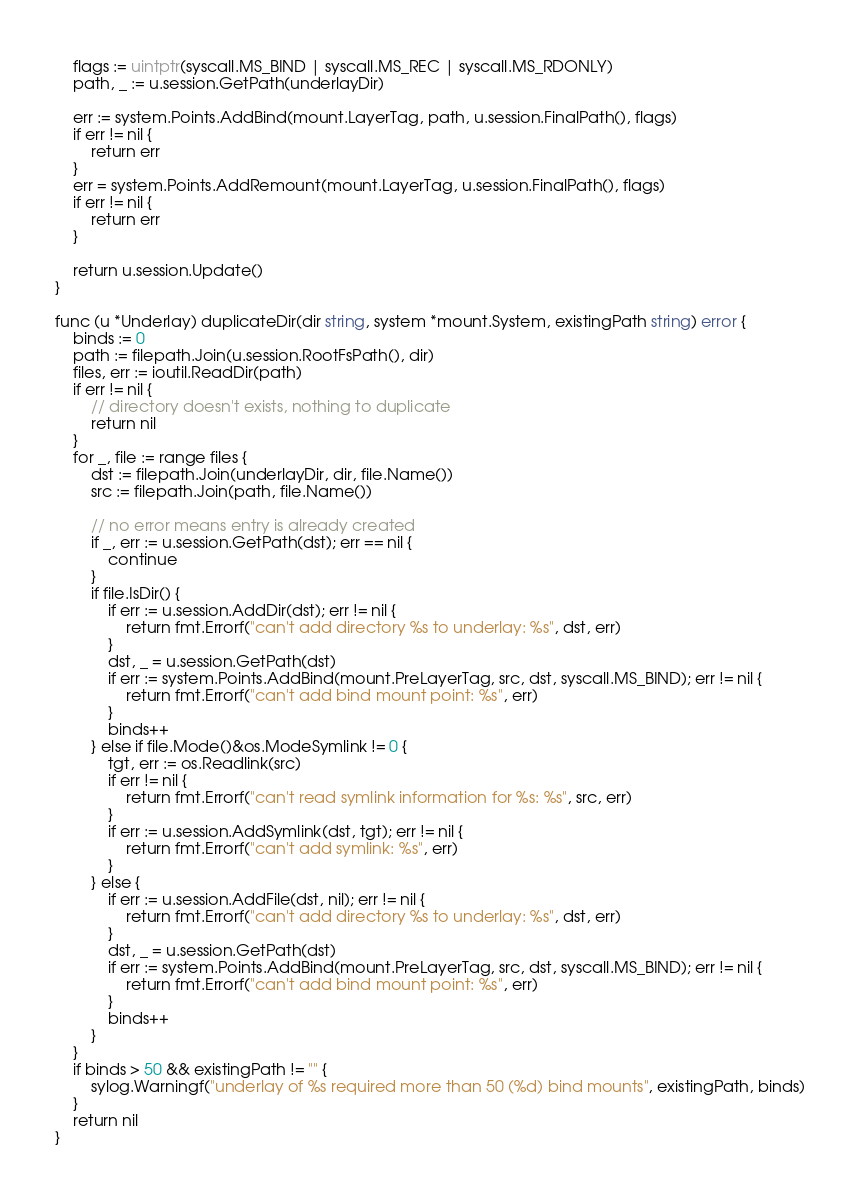<code> <loc_0><loc_0><loc_500><loc_500><_Go_>
	flags := uintptr(syscall.MS_BIND | syscall.MS_REC | syscall.MS_RDONLY)
	path, _ := u.session.GetPath(underlayDir)

	err := system.Points.AddBind(mount.LayerTag, path, u.session.FinalPath(), flags)
	if err != nil {
		return err
	}
	err = system.Points.AddRemount(mount.LayerTag, u.session.FinalPath(), flags)
	if err != nil {
		return err
	}

	return u.session.Update()
}

func (u *Underlay) duplicateDir(dir string, system *mount.System, existingPath string) error {
	binds := 0
	path := filepath.Join(u.session.RootFsPath(), dir)
	files, err := ioutil.ReadDir(path)
	if err != nil {
		// directory doesn't exists, nothing to duplicate
		return nil
	}
	for _, file := range files {
		dst := filepath.Join(underlayDir, dir, file.Name())
		src := filepath.Join(path, file.Name())

		// no error means entry is already created
		if _, err := u.session.GetPath(dst); err == nil {
			continue
		}
		if file.IsDir() {
			if err := u.session.AddDir(dst); err != nil {
				return fmt.Errorf("can't add directory %s to underlay: %s", dst, err)
			}
			dst, _ = u.session.GetPath(dst)
			if err := system.Points.AddBind(mount.PreLayerTag, src, dst, syscall.MS_BIND); err != nil {
				return fmt.Errorf("can't add bind mount point: %s", err)
			}
			binds++
		} else if file.Mode()&os.ModeSymlink != 0 {
			tgt, err := os.Readlink(src)
			if err != nil {
				return fmt.Errorf("can't read symlink information for %s: %s", src, err)
			}
			if err := u.session.AddSymlink(dst, tgt); err != nil {
				return fmt.Errorf("can't add symlink: %s", err)
			}
		} else {
			if err := u.session.AddFile(dst, nil); err != nil {
				return fmt.Errorf("can't add directory %s to underlay: %s", dst, err)
			}
			dst, _ = u.session.GetPath(dst)
			if err := system.Points.AddBind(mount.PreLayerTag, src, dst, syscall.MS_BIND); err != nil {
				return fmt.Errorf("can't add bind mount point: %s", err)
			}
			binds++
		}
	}
	if binds > 50 && existingPath != "" {
		sylog.Warningf("underlay of %s required more than 50 (%d) bind mounts", existingPath, binds)
	}
	return nil
}
</code> 